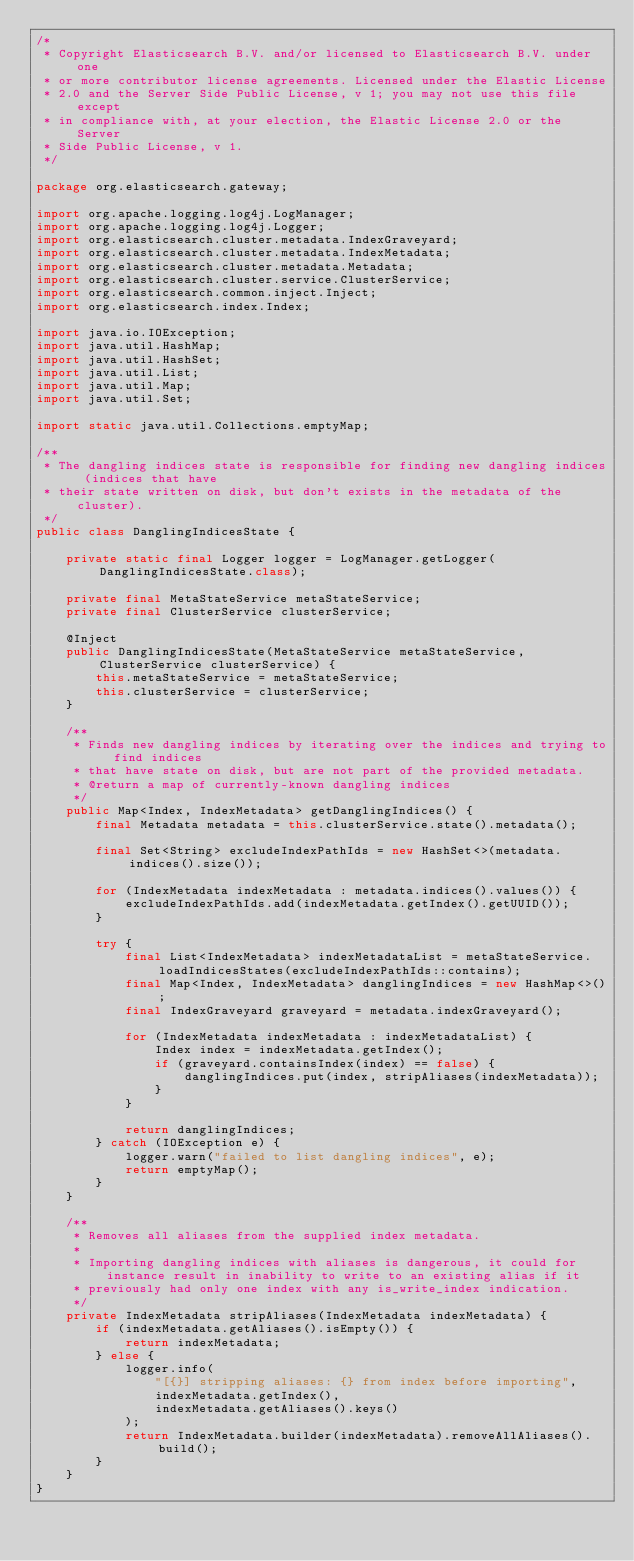<code> <loc_0><loc_0><loc_500><loc_500><_Java_>/*
 * Copyright Elasticsearch B.V. and/or licensed to Elasticsearch B.V. under one
 * or more contributor license agreements. Licensed under the Elastic License
 * 2.0 and the Server Side Public License, v 1; you may not use this file except
 * in compliance with, at your election, the Elastic License 2.0 or the Server
 * Side Public License, v 1.
 */

package org.elasticsearch.gateway;

import org.apache.logging.log4j.LogManager;
import org.apache.logging.log4j.Logger;
import org.elasticsearch.cluster.metadata.IndexGraveyard;
import org.elasticsearch.cluster.metadata.IndexMetadata;
import org.elasticsearch.cluster.metadata.Metadata;
import org.elasticsearch.cluster.service.ClusterService;
import org.elasticsearch.common.inject.Inject;
import org.elasticsearch.index.Index;

import java.io.IOException;
import java.util.HashMap;
import java.util.HashSet;
import java.util.List;
import java.util.Map;
import java.util.Set;

import static java.util.Collections.emptyMap;

/**
 * The dangling indices state is responsible for finding new dangling indices (indices that have
 * their state written on disk, but don't exists in the metadata of the cluster).
 */
public class DanglingIndicesState {

    private static final Logger logger = LogManager.getLogger(DanglingIndicesState.class);

    private final MetaStateService metaStateService;
    private final ClusterService clusterService;

    @Inject
    public DanglingIndicesState(MetaStateService metaStateService, ClusterService clusterService) {
        this.metaStateService = metaStateService;
        this.clusterService = clusterService;
    }

    /**
     * Finds new dangling indices by iterating over the indices and trying to find indices
     * that have state on disk, but are not part of the provided metadata.
     * @return a map of currently-known dangling indices
     */
    public Map<Index, IndexMetadata> getDanglingIndices() {
        final Metadata metadata = this.clusterService.state().metadata();

        final Set<String> excludeIndexPathIds = new HashSet<>(metadata.indices().size());

        for (IndexMetadata indexMetadata : metadata.indices().values()) {
            excludeIndexPathIds.add(indexMetadata.getIndex().getUUID());
        }

        try {
            final List<IndexMetadata> indexMetadataList = metaStateService.loadIndicesStates(excludeIndexPathIds::contains);
            final Map<Index, IndexMetadata> danglingIndices = new HashMap<>();
            final IndexGraveyard graveyard = metadata.indexGraveyard();

            for (IndexMetadata indexMetadata : indexMetadataList) {
                Index index = indexMetadata.getIndex();
                if (graveyard.containsIndex(index) == false) {
                    danglingIndices.put(index, stripAliases(indexMetadata));
                }
            }

            return danglingIndices;
        } catch (IOException e) {
            logger.warn("failed to list dangling indices", e);
            return emptyMap();
        }
    }

    /**
     * Removes all aliases from the supplied index metadata.
     *
     * Importing dangling indices with aliases is dangerous, it could for instance result in inability to write to an existing alias if it
     * previously had only one index with any is_write_index indication.
     */
    private IndexMetadata stripAliases(IndexMetadata indexMetadata) {
        if (indexMetadata.getAliases().isEmpty()) {
            return indexMetadata;
        } else {
            logger.info(
                "[{}] stripping aliases: {} from index before importing",
                indexMetadata.getIndex(),
                indexMetadata.getAliases().keys()
            );
            return IndexMetadata.builder(indexMetadata).removeAllAliases().build();
        }
    }
}
</code> 